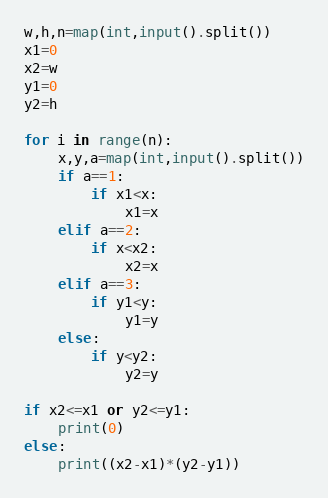<code> <loc_0><loc_0><loc_500><loc_500><_Python_>w,h,n=map(int,input().split())
x1=0
x2=w
y1=0
y2=h

for i in range(n):
    x,y,a=map(int,input().split())
    if a==1:
        if x1<x:
            x1=x
    elif a==2:
        if x<x2:
            x2=x
    elif a==3:
        if y1<y:
            y1=y
    else:
        if y<y2:
            y2=y

if x2<=x1 or y2<=y1:
    print(0)
else:
    print((x2-x1)*(y2-y1))</code> 